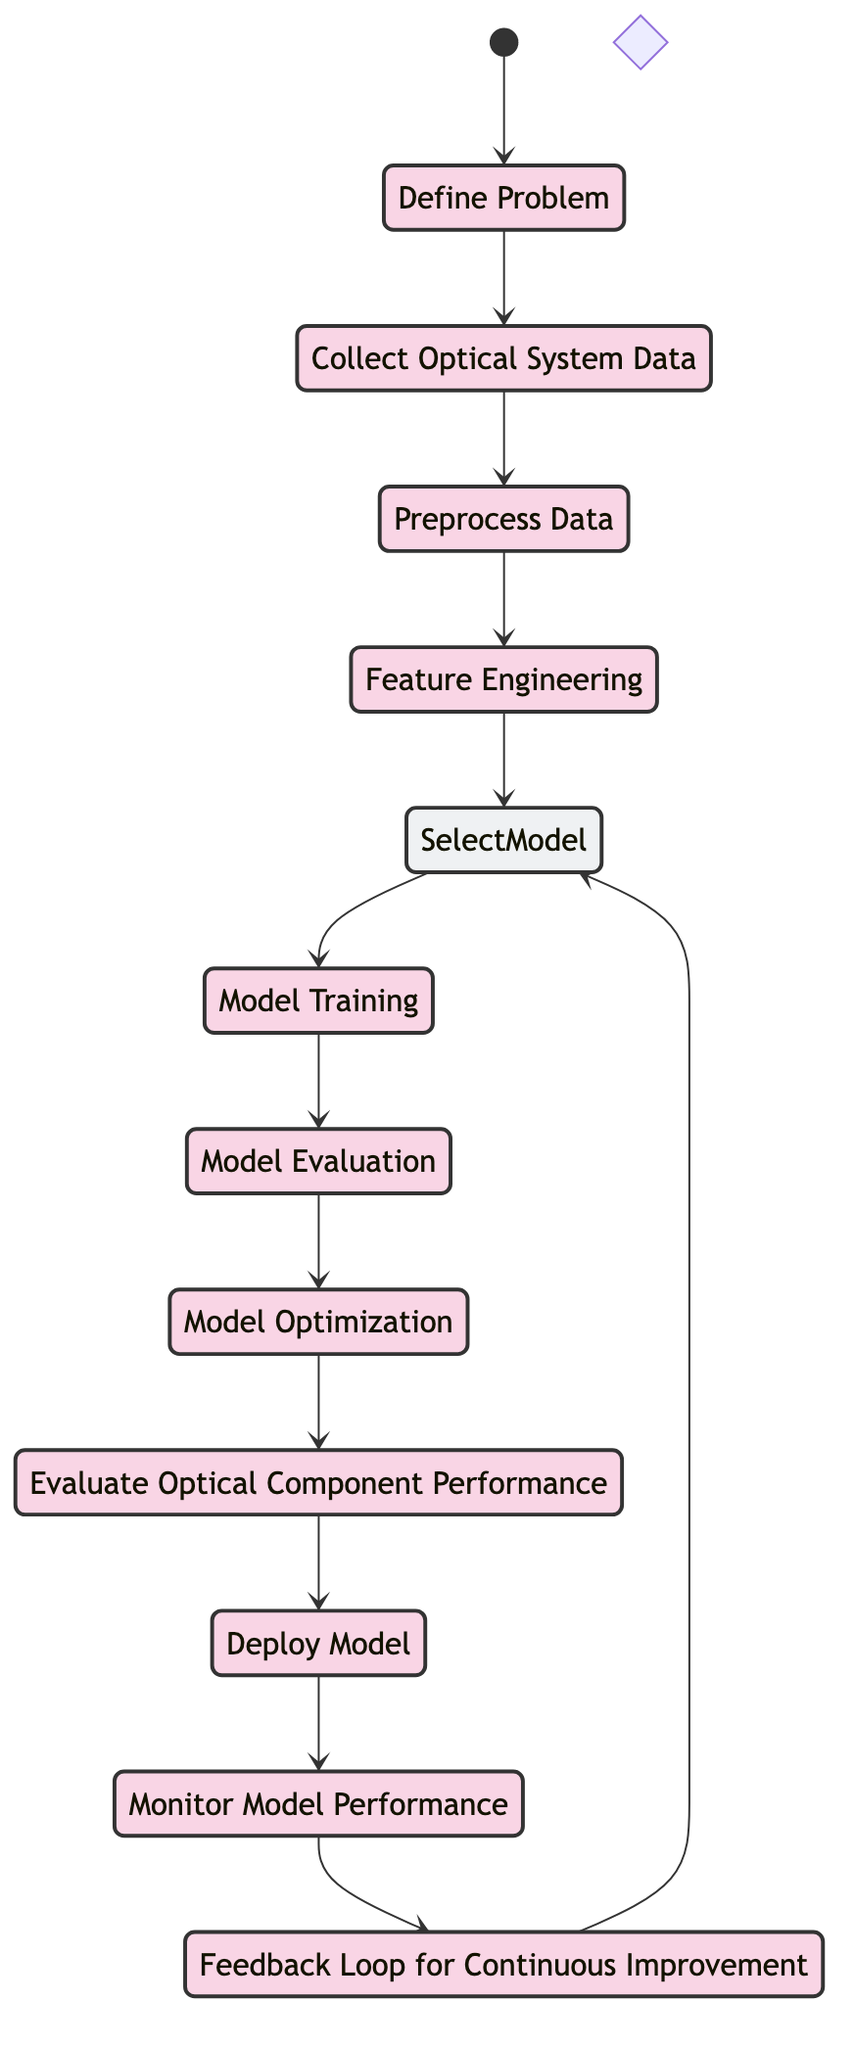What is the first activity in the diagram? The diagram starts with an initial state labeled "Define Problem," which is the first activity that follows the start state.
Answer: Define Problem How many activities are there in total? The diagram contains a total of eleven activities that are distinctly denoted.
Answer: Eleven What follows after "Feature Engineering"? After "Feature Engineering," the flow moves to "Select Machine Learning Model," indicating the next step in the development process.
Answer: Select Machine Learning Model Identify the decision point in the diagram. The decision point in the diagram is represented by "Select Machine Learning Model," which is a diamond-shaped node indicating a choice in the flow.
Answer: Select Machine Learning Model What is the final activity before the feedback loop? The final activity leading into the feedback loop is "Monitor Model Performance," which allows for assessing the model's effectiveness before revisiting previous steps.
Answer: Monitor Model Performance How many nodes lead into the "Model Evaluation"? The "Model Evaluation" node is reached by a single preceding activity, which is "Model Training," making the count of nodes leading into it one.
Answer: One Which activity occurs immediately after "Deploy Model"? The activity that takes place immediately after "Deploy Model" is "Monitor Model Performance," indicating the next step in the operational phase of the project.
Answer: Monitor Model Performance Describe the relationship between "Model Optimization" and "Evaluate Optical Component Performance." The flow from "Model Optimization" leads directly to "Evaluate Optical Component Performance," illustrating a sequential dependency where optimization precedes evaluation.
Answer: Model Optimization to Evaluate Optical Component Performance What is the purpose of the feedback loop? The feedback loop, represented by "Feedback Loop for Continuous Improvement," is intended to revisit the "Select Machine Learning Model" step for further enhancement based on the evaluation outcomes.
Answer: Continuous Improvement 